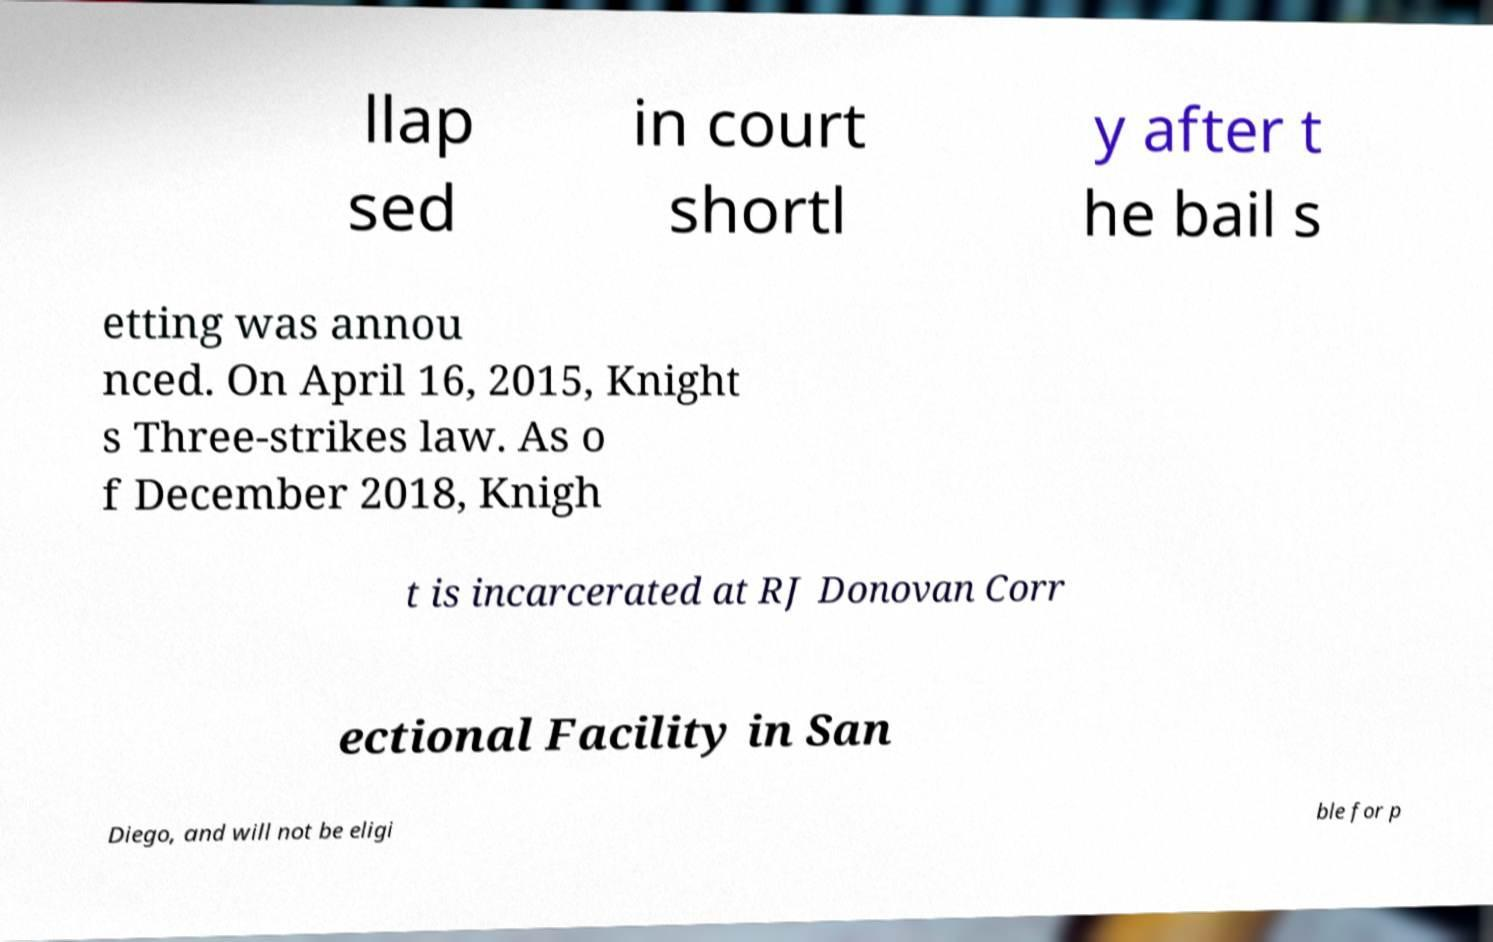Please identify and transcribe the text found in this image. llap sed in court shortl y after t he bail s etting was annou nced. On April 16, 2015, Knight s Three-strikes law. As o f December 2018, Knigh t is incarcerated at RJ Donovan Corr ectional Facility in San Diego, and will not be eligi ble for p 